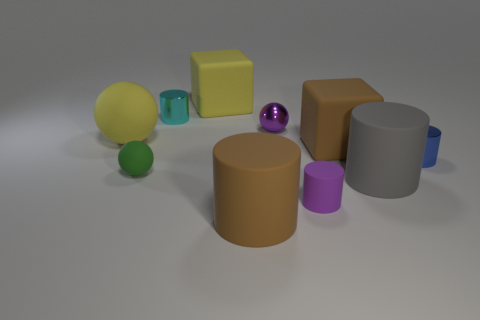Can you describe the texture of the objects? Certainly. The objects in the image have differing textures. The spheres and the cylinder on the left side exhibit smooth and glossy finishes, reflecting light and giving off a sense of softness. In contrast, the cube and the large brown and gray cylinders have matte finishes, diffusing the light and providing a sense of solidity and roughness. 